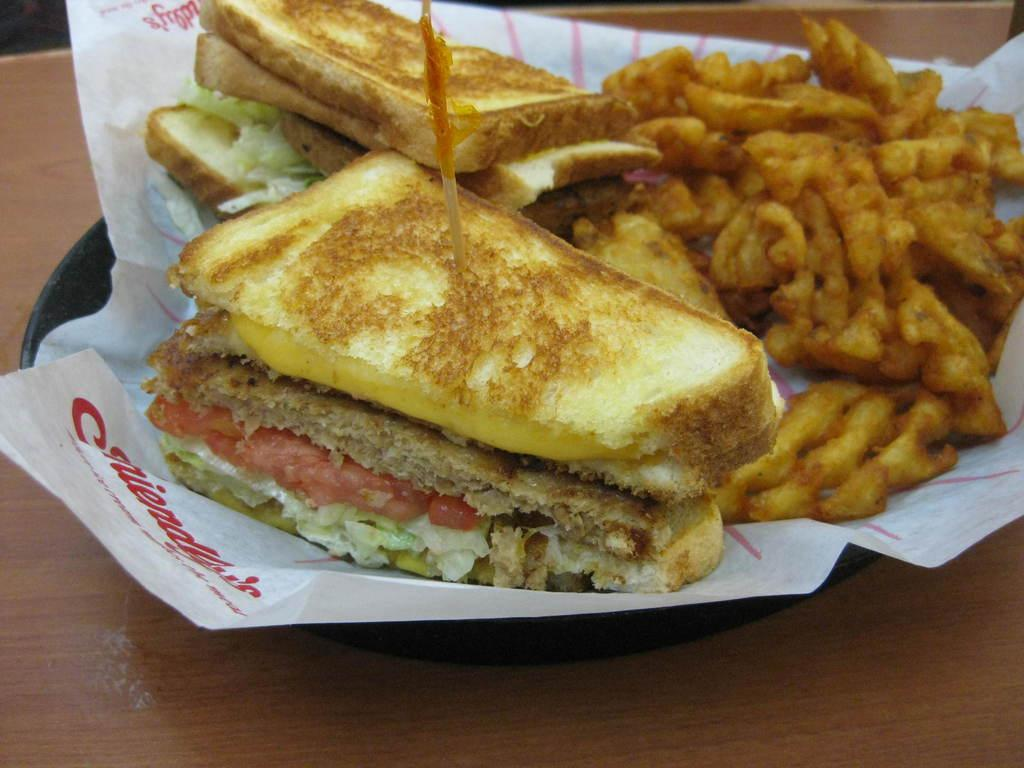What types of items can be seen in the image? There are food items in the image. What is placed on the plate with the food items? There is a paper in the plate. On what surface is the plate resting? The plate is placed on a wooden platform. What is the range of emotions displayed on the representative's face in the image? There is no representative or face present in the image; it only features food items, a paper, and a wooden platform. 